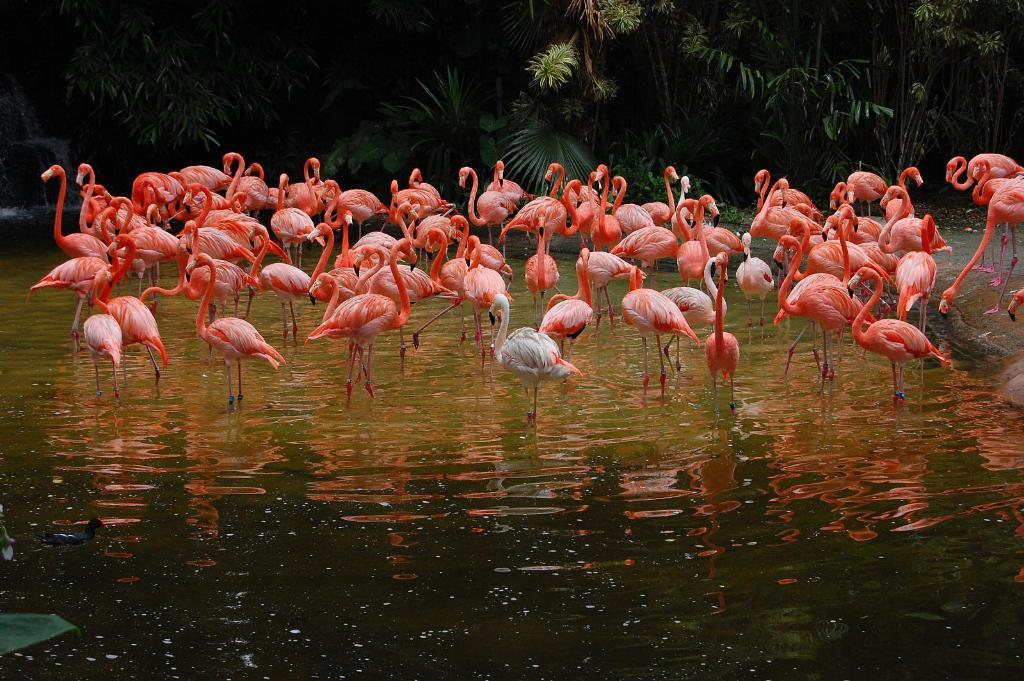What animals can be seen in the water in the image? There is a group of swans in the water in the image. What type of natural environment is depicted in the image? There are trees and plants visible in the image. What feature can be seen on the left side of the image? There is a waterfall on the left side of the image. What type of pet can be seen in the advertisement in the image? There is no pet or advertisement present in the image; it features a group of swans in the water, trees and plants, and a waterfall. 